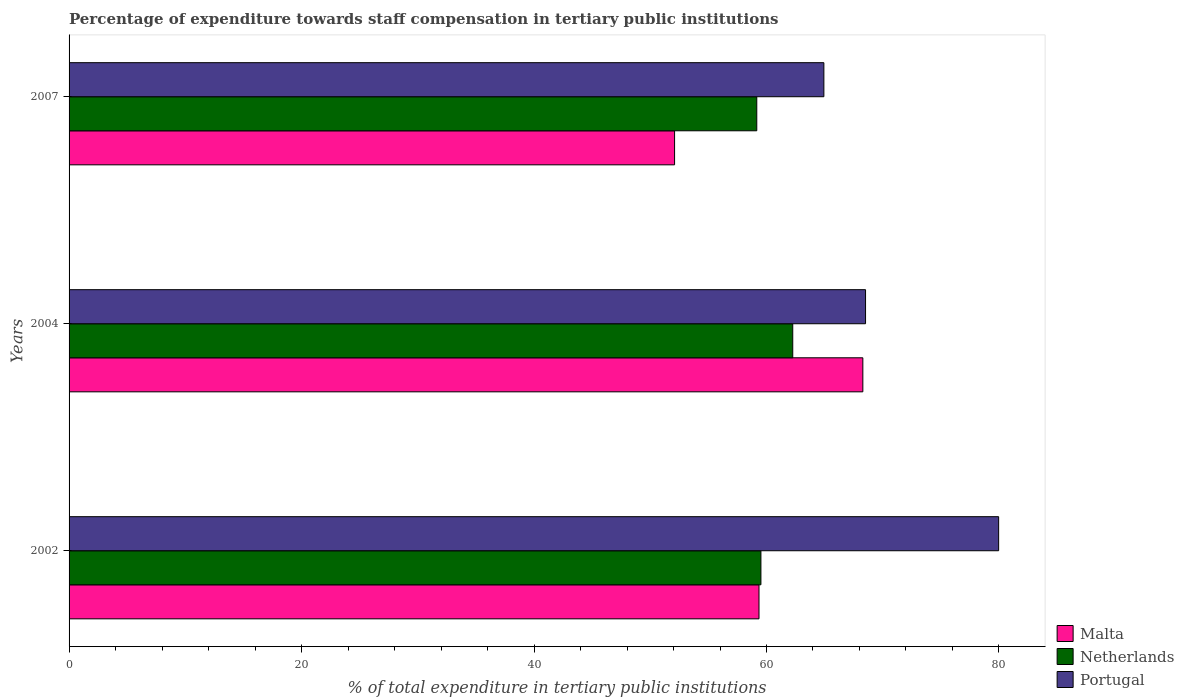How many different coloured bars are there?
Your response must be concise. 3. How many groups of bars are there?
Offer a terse response. 3. In how many cases, is the number of bars for a given year not equal to the number of legend labels?
Offer a very short reply. 0. What is the percentage of expenditure towards staff compensation in Netherlands in 2007?
Your answer should be compact. 59.17. Across all years, what is the maximum percentage of expenditure towards staff compensation in Malta?
Offer a very short reply. 68.29. Across all years, what is the minimum percentage of expenditure towards staff compensation in Malta?
Your response must be concise. 52.09. In which year was the percentage of expenditure towards staff compensation in Netherlands maximum?
Give a very brief answer. 2004. In which year was the percentage of expenditure towards staff compensation in Malta minimum?
Give a very brief answer. 2007. What is the total percentage of expenditure towards staff compensation in Portugal in the graph?
Your response must be concise. 213.43. What is the difference between the percentage of expenditure towards staff compensation in Netherlands in 2002 and that in 2007?
Your answer should be compact. 0.36. What is the difference between the percentage of expenditure towards staff compensation in Portugal in 2004 and the percentage of expenditure towards staff compensation in Netherlands in 2007?
Provide a short and direct response. 9.36. What is the average percentage of expenditure towards staff compensation in Malta per year?
Offer a very short reply. 59.91. In the year 2007, what is the difference between the percentage of expenditure towards staff compensation in Netherlands and percentage of expenditure towards staff compensation in Malta?
Provide a succinct answer. 7.07. What is the ratio of the percentage of expenditure towards staff compensation in Portugal in 2002 to that in 2007?
Give a very brief answer. 1.23. Is the percentage of expenditure towards staff compensation in Portugal in 2004 less than that in 2007?
Ensure brevity in your answer.  No. What is the difference between the highest and the second highest percentage of expenditure towards staff compensation in Malta?
Offer a very short reply. 8.93. What is the difference between the highest and the lowest percentage of expenditure towards staff compensation in Portugal?
Your response must be concise. 15.04. Is the sum of the percentage of expenditure towards staff compensation in Portugal in 2002 and 2007 greater than the maximum percentage of expenditure towards staff compensation in Netherlands across all years?
Provide a short and direct response. Yes. What does the 3rd bar from the top in 2002 represents?
Your answer should be compact. Malta. What does the 3rd bar from the bottom in 2004 represents?
Provide a short and direct response. Portugal. How many bars are there?
Keep it short and to the point. 9. Are all the bars in the graph horizontal?
Make the answer very short. Yes. How many years are there in the graph?
Provide a short and direct response. 3. What is the difference between two consecutive major ticks on the X-axis?
Make the answer very short. 20. Are the values on the major ticks of X-axis written in scientific E-notation?
Provide a short and direct response. No. Does the graph contain any zero values?
Your answer should be compact. No. Does the graph contain grids?
Your answer should be very brief. No. Where does the legend appear in the graph?
Ensure brevity in your answer.  Bottom right. How many legend labels are there?
Your answer should be compact. 3. How are the legend labels stacked?
Make the answer very short. Vertical. What is the title of the graph?
Your answer should be compact. Percentage of expenditure towards staff compensation in tertiary public institutions. What is the label or title of the X-axis?
Offer a very short reply. % of total expenditure in tertiary public institutions. What is the label or title of the Y-axis?
Your answer should be very brief. Years. What is the % of total expenditure in tertiary public institutions in Malta in 2002?
Your answer should be very brief. 59.36. What is the % of total expenditure in tertiary public institutions of Netherlands in 2002?
Your answer should be very brief. 59.52. What is the % of total expenditure in tertiary public institutions of Portugal in 2002?
Keep it short and to the point. 79.97. What is the % of total expenditure in tertiary public institutions in Malta in 2004?
Give a very brief answer. 68.29. What is the % of total expenditure in tertiary public institutions in Netherlands in 2004?
Give a very brief answer. 62.26. What is the % of total expenditure in tertiary public institutions in Portugal in 2004?
Keep it short and to the point. 68.52. What is the % of total expenditure in tertiary public institutions in Malta in 2007?
Keep it short and to the point. 52.09. What is the % of total expenditure in tertiary public institutions of Netherlands in 2007?
Provide a succinct answer. 59.17. What is the % of total expenditure in tertiary public institutions of Portugal in 2007?
Provide a succinct answer. 64.94. Across all years, what is the maximum % of total expenditure in tertiary public institutions in Malta?
Your answer should be very brief. 68.29. Across all years, what is the maximum % of total expenditure in tertiary public institutions of Netherlands?
Your answer should be very brief. 62.26. Across all years, what is the maximum % of total expenditure in tertiary public institutions of Portugal?
Give a very brief answer. 79.97. Across all years, what is the minimum % of total expenditure in tertiary public institutions of Malta?
Provide a succinct answer. 52.09. Across all years, what is the minimum % of total expenditure in tertiary public institutions of Netherlands?
Provide a succinct answer. 59.17. Across all years, what is the minimum % of total expenditure in tertiary public institutions in Portugal?
Keep it short and to the point. 64.94. What is the total % of total expenditure in tertiary public institutions in Malta in the graph?
Ensure brevity in your answer.  179.74. What is the total % of total expenditure in tertiary public institutions of Netherlands in the graph?
Provide a succinct answer. 180.95. What is the total % of total expenditure in tertiary public institutions of Portugal in the graph?
Offer a very short reply. 213.43. What is the difference between the % of total expenditure in tertiary public institutions in Malta in 2002 and that in 2004?
Offer a terse response. -8.93. What is the difference between the % of total expenditure in tertiary public institutions in Netherlands in 2002 and that in 2004?
Your answer should be compact. -2.74. What is the difference between the % of total expenditure in tertiary public institutions of Portugal in 2002 and that in 2004?
Offer a terse response. 11.45. What is the difference between the % of total expenditure in tertiary public institutions of Malta in 2002 and that in 2007?
Provide a short and direct response. 7.26. What is the difference between the % of total expenditure in tertiary public institutions in Netherlands in 2002 and that in 2007?
Ensure brevity in your answer.  0.36. What is the difference between the % of total expenditure in tertiary public institutions in Portugal in 2002 and that in 2007?
Make the answer very short. 15.04. What is the difference between the % of total expenditure in tertiary public institutions in Malta in 2004 and that in 2007?
Provide a short and direct response. 16.2. What is the difference between the % of total expenditure in tertiary public institutions in Netherlands in 2004 and that in 2007?
Provide a short and direct response. 3.09. What is the difference between the % of total expenditure in tertiary public institutions in Portugal in 2004 and that in 2007?
Offer a terse response. 3.59. What is the difference between the % of total expenditure in tertiary public institutions in Malta in 2002 and the % of total expenditure in tertiary public institutions in Netherlands in 2004?
Provide a short and direct response. -2.9. What is the difference between the % of total expenditure in tertiary public institutions of Malta in 2002 and the % of total expenditure in tertiary public institutions of Portugal in 2004?
Your response must be concise. -9.17. What is the difference between the % of total expenditure in tertiary public institutions in Netherlands in 2002 and the % of total expenditure in tertiary public institutions in Portugal in 2004?
Make the answer very short. -9. What is the difference between the % of total expenditure in tertiary public institutions of Malta in 2002 and the % of total expenditure in tertiary public institutions of Netherlands in 2007?
Give a very brief answer. 0.19. What is the difference between the % of total expenditure in tertiary public institutions in Malta in 2002 and the % of total expenditure in tertiary public institutions in Portugal in 2007?
Make the answer very short. -5.58. What is the difference between the % of total expenditure in tertiary public institutions of Netherlands in 2002 and the % of total expenditure in tertiary public institutions of Portugal in 2007?
Offer a terse response. -5.42. What is the difference between the % of total expenditure in tertiary public institutions in Malta in 2004 and the % of total expenditure in tertiary public institutions in Netherlands in 2007?
Ensure brevity in your answer.  9.12. What is the difference between the % of total expenditure in tertiary public institutions of Malta in 2004 and the % of total expenditure in tertiary public institutions of Portugal in 2007?
Offer a terse response. 3.35. What is the difference between the % of total expenditure in tertiary public institutions in Netherlands in 2004 and the % of total expenditure in tertiary public institutions in Portugal in 2007?
Offer a terse response. -2.68. What is the average % of total expenditure in tertiary public institutions in Malta per year?
Offer a terse response. 59.91. What is the average % of total expenditure in tertiary public institutions in Netherlands per year?
Ensure brevity in your answer.  60.32. What is the average % of total expenditure in tertiary public institutions in Portugal per year?
Give a very brief answer. 71.14. In the year 2002, what is the difference between the % of total expenditure in tertiary public institutions in Malta and % of total expenditure in tertiary public institutions in Netherlands?
Make the answer very short. -0.17. In the year 2002, what is the difference between the % of total expenditure in tertiary public institutions of Malta and % of total expenditure in tertiary public institutions of Portugal?
Offer a terse response. -20.62. In the year 2002, what is the difference between the % of total expenditure in tertiary public institutions of Netherlands and % of total expenditure in tertiary public institutions of Portugal?
Provide a short and direct response. -20.45. In the year 2004, what is the difference between the % of total expenditure in tertiary public institutions of Malta and % of total expenditure in tertiary public institutions of Netherlands?
Keep it short and to the point. 6.03. In the year 2004, what is the difference between the % of total expenditure in tertiary public institutions of Malta and % of total expenditure in tertiary public institutions of Portugal?
Keep it short and to the point. -0.23. In the year 2004, what is the difference between the % of total expenditure in tertiary public institutions in Netherlands and % of total expenditure in tertiary public institutions in Portugal?
Offer a very short reply. -6.26. In the year 2007, what is the difference between the % of total expenditure in tertiary public institutions in Malta and % of total expenditure in tertiary public institutions in Netherlands?
Your answer should be very brief. -7.07. In the year 2007, what is the difference between the % of total expenditure in tertiary public institutions of Malta and % of total expenditure in tertiary public institutions of Portugal?
Make the answer very short. -12.84. In the year 2007, what is the difference between the % of total expenditure in tertiary public institutions of Netherlands and % of total expenditure in tertiary public institutions of Portugal?
Keep it short and to the point. -5.77. What is the ratio of the % of total expenditure in tertiary public institutions of Malta in 2002 to that in 2004?
Give a very brief answer. 0.87. What is the ratio of the % of total expenditure in tertiary public institutions in Netherlands in 2002 to that in 2004?
Provide a succinct answer. 0.96. What is the ratio of the % of total expenditure in tertiary public institutions in Portugal in 2002 to that in 2004?
Offer a terse response. 1.17. What is the ratio of the % of total expenditure in tertiary public institutions of Malta in 2002 to that in 2007?
Provide a succinct answer. 1.14. What is the ratio of the % of total expenditure in tertiary public institutions in Netherlands in 2002 to that in 2007?
Your answer should be compact. 1.01. What is the ratio of the % of total expenditure in tertiary public institutions in Portugal in 2002 to that in 2007?
Give a very brief answer. 1.23. What is the ratio of the % of total expenditure in tertiary public institutions in Malta in 2004 to that in 2007?
Ensure brevity in your answer.  1.31. What is the ratio of the % of total expenditure in tertiary public institutions of Netherlands in 2004 to that in 2007?
Offer a terse response. 1.05. What is the ratio of the % of total expenditure in tertiary public institutions of Portugal in 2004 to that in 2007?
Provide a succinct answer. 1.06. What is the difference between the highest and the second highest % of total expenditure in tertiary public institutions in Malta?
Your answer should be very brief. 8.93. What is the difference between the highest and the second highest % of total expenditure in tertiary public institutions in Netherlands?
Provide a succinct answer. 2.74. What is the difference between the highest and the second highest % of total expenditure in tertiary public institutions of Portugal?
Provide a succinct answer. 11.45. What is the difference between the highest and the lowest % of total expenditure in tertiary public institutions in Malta?
Your answer should be compact. 16.2. What is the difference between the highest and the lowest % of total expenditure in tertiary public institutions of Netherlands?
Your answer should be compact. 3.09. What is the difference between the highest and the lowest % of total expenditure in tertiary public institutions of Portugal?
Provide a succinct answer. 15.04. 